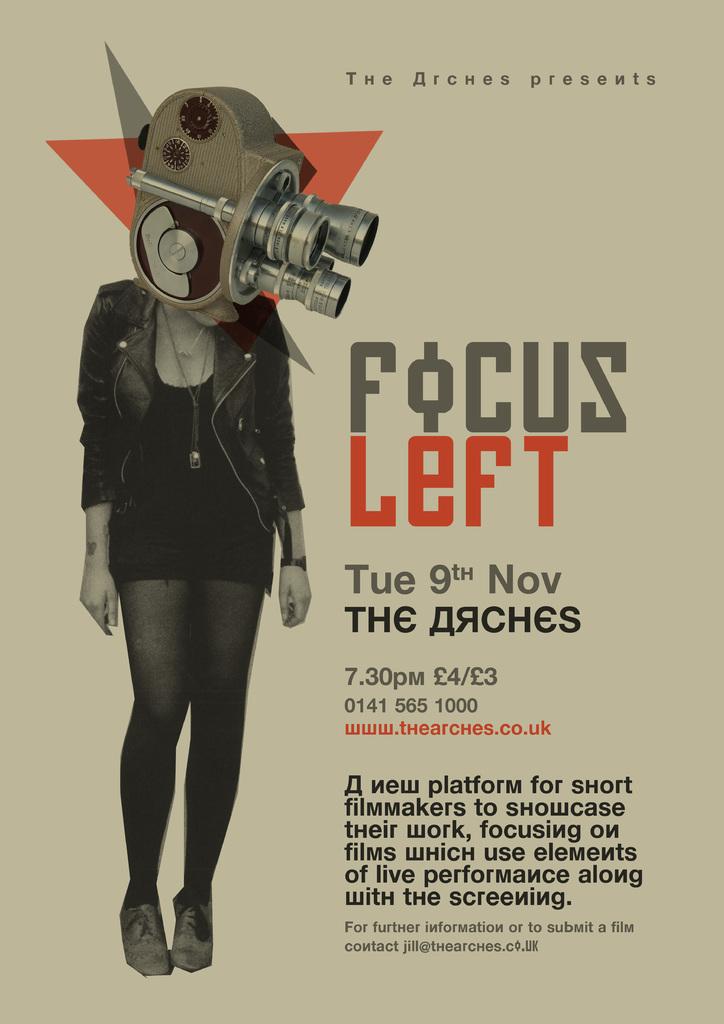What is the price of this?
Offer a terse response. Unanswerable. What date does this take place?
Give a very brief answer. Tue 9th nov. 